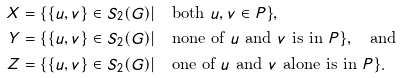Convert formula to latex. <formula><loc_0><loc_0><loc_500><loc_500>X & = \{ \{ u , v \} \in S _ { 2 } ( G ) | \quad \text {both} \ u , v \in P \} , \\ Y & = \{ \{ u , v \} \in S _ { 2 } ( G ) | \quad \text {none of $u$ and $v$ is in $P$} \} , \quad \text {and} \\ Z & = \{ \{ u , v \} \in S _ { 2 } ( G ) | \quad \text {one of $u$ and $v$ alone is in $P$} \} .</formula> 